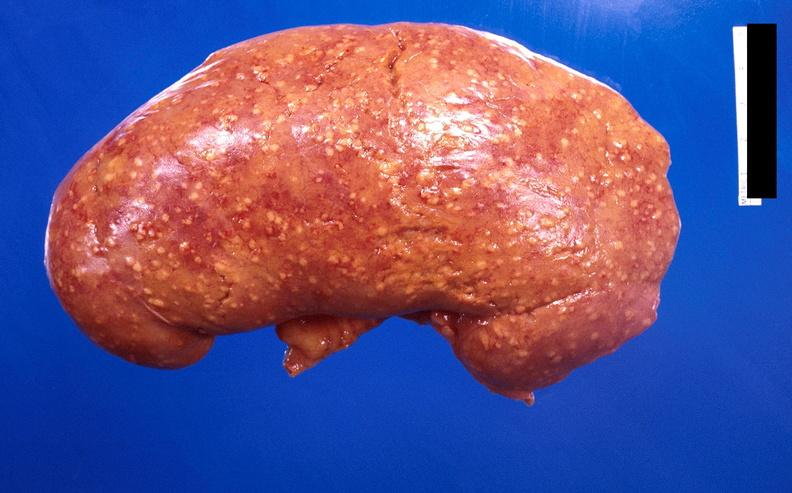does this image show kidney, candida abscesses?
Answer the question using a single word or phrase. Yes 